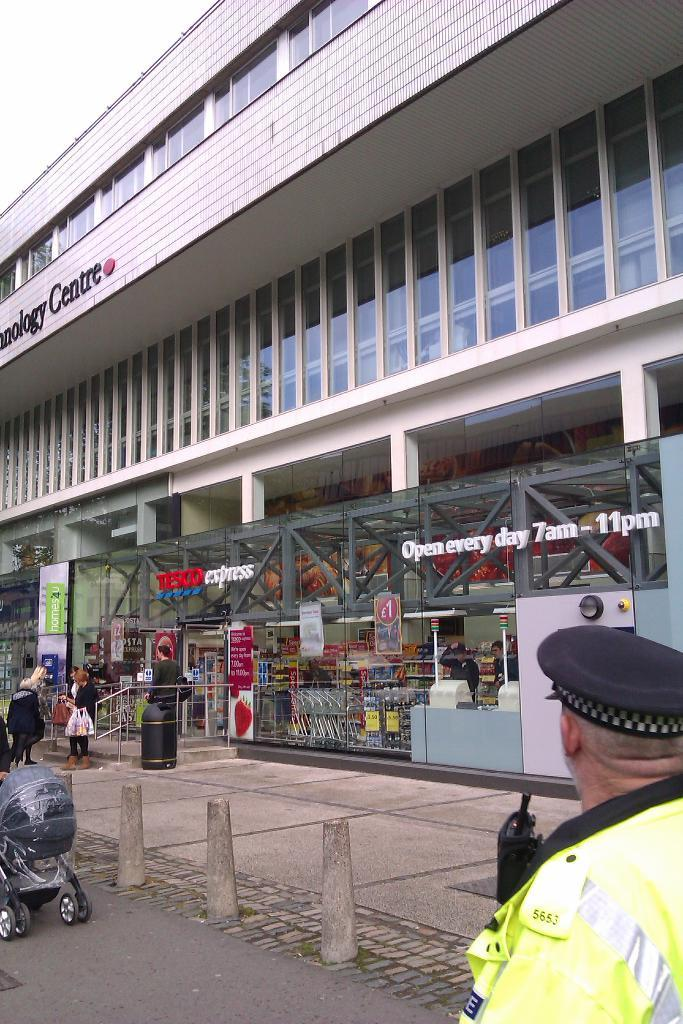What are the people in the image doing? The people in the image are standing on the road. What structure can be seen in the background of the image? There is a building in the image. What type of building is it? The building is a shopping mall. What impulse did the people standing on the road have in the image? There is no information about any impulses or motivations of the people in the image, so we cannot answer this question. 